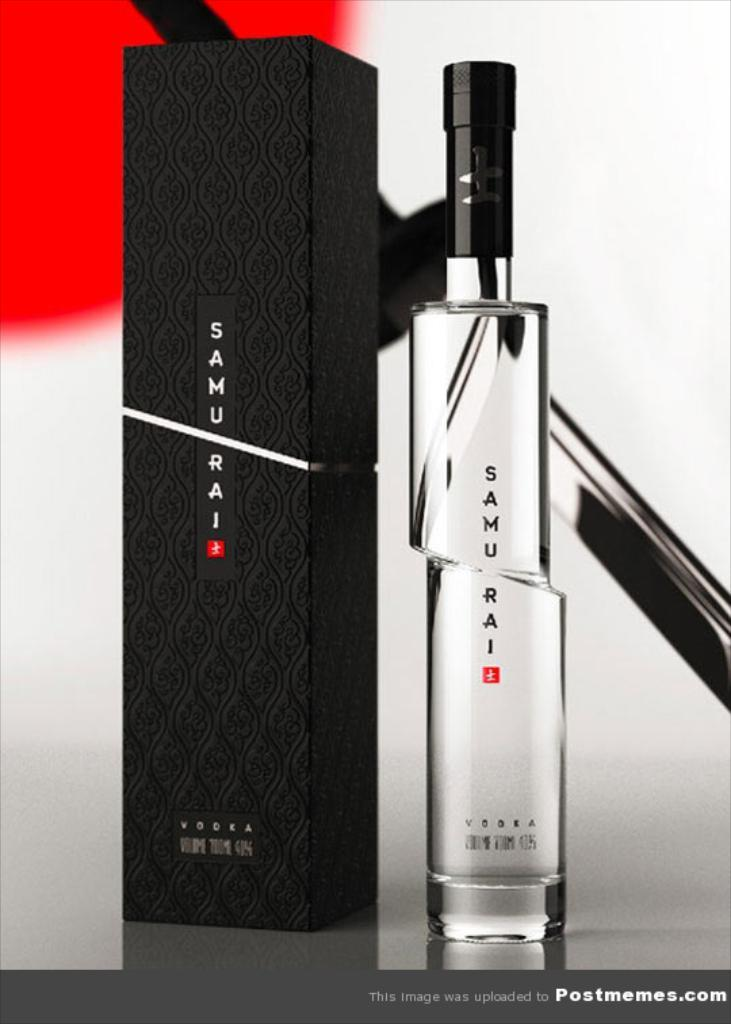<image>
Write a terse but informative summary of the picture. A glass bottle and box beside each other of Samurai. 